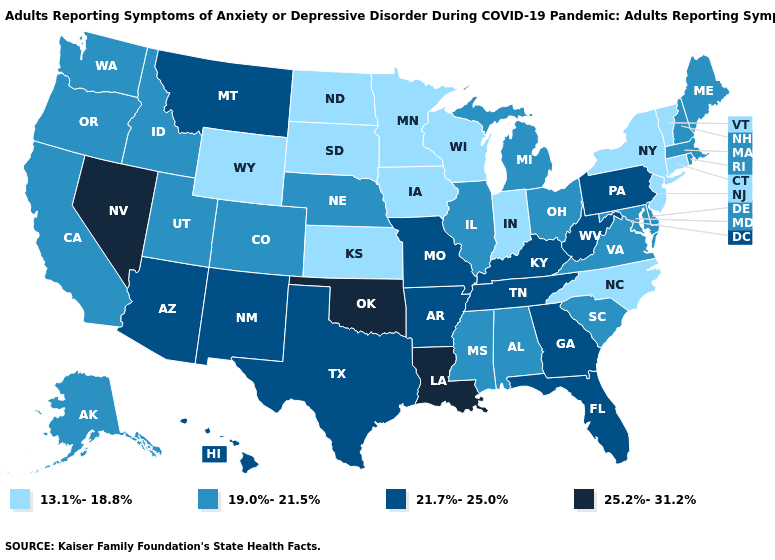What is the lowest value in the USA?
Keep it brief. 13.1%-18.8%. Does Louisiana have the highest value in the USA?
Quick response, please. Yes. Which states have the lowest value in the Northeast?
Be succinct. Connecticut, New Jersey, New York, Vermont. Does Mississippi have the same value as Delaware?
Write a very short answer. Yes. Does Alaska have the lowest value in the West?
Be succinct. No. What is the value of Maine?
Be succinct. 19.0%-21.5%. Name the states that have a value in the range 13.1%-18.8%?
Short answer required. Connecticut, Indiana, Iowa, Kansas, Minnesota, New Jersey, New York, North Carolina, North Dakota, South Dakota, Vermont, Wisconsin, Wyoming. Name the states that have a value in the range 21.7%-25.0%?
Answer briefly. Arizona, Arkansas, Florida, Georgia, Hawaii, Kentucky, Missouri, Montana, New Mexico, Pennsylvania, Tennessee, Texas, West Virginia. Does Missouri have the highest value in the MidWest?
Be succinct. Yes. Which states have the highest value in the USA?
Quick response, please. Louisiana, Nevada, Oklahoma. Name the states that have a value in the range 21.7%-25.0%?
Be succinct. Arizona, Arkansas, Florida, Georgia, Hawaii, Kentucky, Missouri, Montana, New Mexico, Pennsylvania, Tennessee, Texas, West Virginia. What is the value of North Carolina?
Answer briefly. 13.1%-18.8%. What is the value of Maine?
Write a very short answer. 19.0%-21.5%. Does New York have the lowest value in the Northeast?
Keep it brief. Yes. Does Texas have a lower value than Tennessee?
Quick response, please. No. 